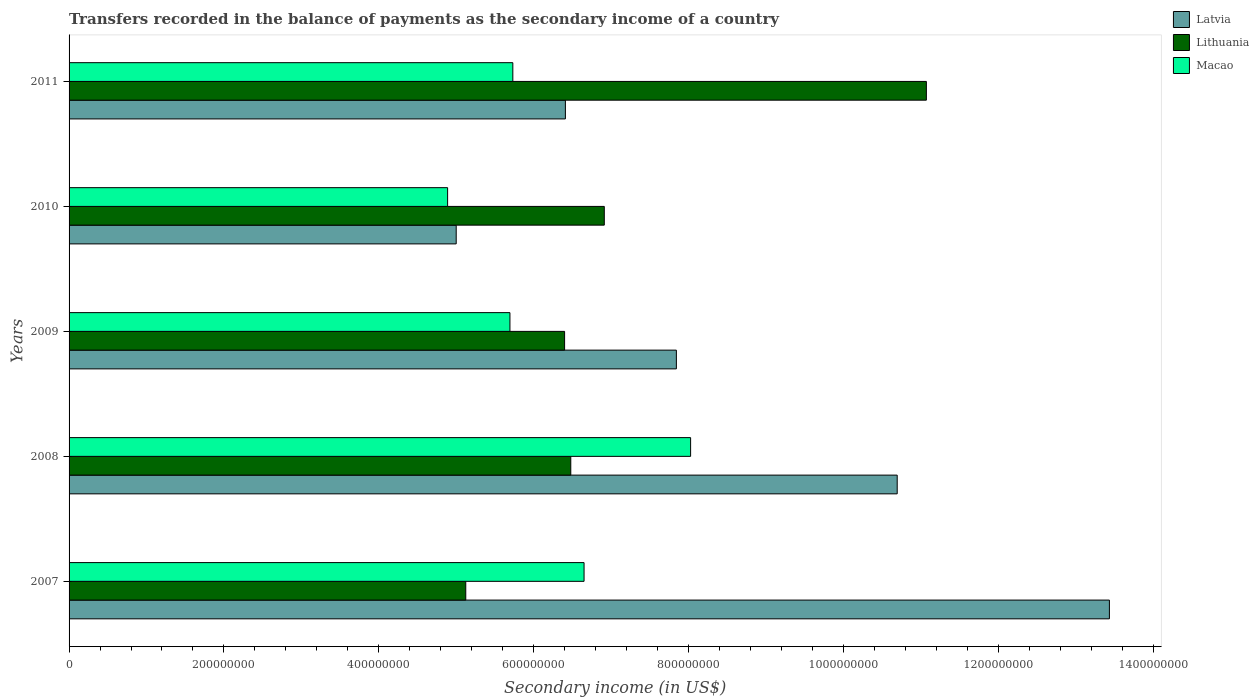How many different coloured bars are there?
Your answer should be compact. 3. Are the number of bars per tick equal to the number of legend labels?
Give a very brief answer. Yes. How many bars are there on the 3rd tick from the bottom?
Provide a short and direct response. 3. What is the label of the 4th group of bars from the top?
Provide a succinct answer. 2008. In how many cases, is the number of bars for a given year not equal to the number of legend labels?
Give a very brief answer. 0. What is the secondary income of in Latvia in 2007?
Provide a succinct answer. 1.34e+09. Across all years, what is the maximum secondary income of in Macao?
Your answer should be very brief. 8.03e+08. Across all years, what is the minimum secondary income of in Lithuania?
Provide a succinct answer. 5.12e+08. What is the total secondary income of in Latvia in the graph?
Your answer should be very brief. 4.34e+09. What is the difference between the secondary income of in Lithuania in 2008 and that in 2011?
Provide a succinct answer. -4.59e+08. What is the difference between the secondary income of in Latvia in 2010 and the secondary income of in Lithuania in 2009?
Your answer should be compact. -1.40e+08. What is the average secondary income of in Latvia per year?
Your answer should be compact. 8.68e+08. In the year 2011, what is the difference between the secondary income of in Lithuania and secondary income of in Latvia?
Give a very brief answer. 4.66e+08. What is the ratio of the secondary income of in Lithuania in 2009 to that in 2010?
Offer a very short reply. 0.93. What is the difference between the highest and the second highest secondary income of in Macao?
Offer a terse response. 1.38e+08. What is the difference between the highest and the lowest secondary income of in Latvia?
Your answer should be compact. 8.44e+08. In how many years, is the secondary income of in Lithuania greater than the average secondary income of in Lithuania taken over all years?
Your answer should be compact. 1. Is the sum of the secondary income of in Latvia in 2008 and 2010 greater than the maximum secondary income of in Macao across all years?
Your answer should be very brief. Yes. What does the 1st bar from the top in 2009 represents?
Offer a very short reply. Macao. What does the 1st bar from the bottom in 2011 represents?
Your response must be concise. Latvia. Is it the case that in every year, the sum of the secondary income of in Lithuania and secondary income of in Latvia is greater than the secondary income of in Macao?
Keep it short and to the point. Yes. Are all the bars in the graph horizontal?
Make the answer very short. Yes. What is the difference between two consecutive major ticks on the X-axis?
Your response must be concise. 2.00e+08. Are the values on the major ticks of X-axis written in scientific E-notation?
Your answer should be very brief. No. How many legend labels are there?
Your response must be concise. 3. How are the legend labels stacked?
Offer a very short reply. Vertical. What is the title of the graph?
Your answer should be very brief. Transfers recorded in the balance of payments as the secondary income of a country. What is the label or title of the X-axis?
Your answer should be compact. Secondary income (in US$). What is the label or title of the Y-axis?
Make the answer very short. Years. What is the Secondary income (in US$) of Latvia in 2007?
Offer a terse response. 1.34e+09. What is the Secondary income (in US$) in Lithuania in 2007?
Your response must be concise. 5.12e+08. What is the Secondary income (in US$) of Macao in 2007?
Keep it short and to the point. 6.65e+08. What is the Secondary income (in US$) of Latvia in 2008?
Make the answer very short. 1.07e+09. What is the Secondary income (in US$) of Lithuania in 2008?
Make the answer very short. 6.48e+08. What is the Secondary income (in US$) of Macao in 2008?
Your answer should be compact. 8.03e+08. What is the Secondary income (in US$) of Latvia in 2009?
Give a very brief answer. 7.84e+08. What is the Secondary income (in US$) of Lithuania in 2009?
Keep it short and to the point. 6.40e+08. What is the Secondary income (in US$) in Macao in 2009?
Ensure brevity in your answer.  5.69e+08. What is the Secondary income (in US$) of Latvia in 2010?
Your answer should be compact. 5.00e+08. What is the Secondary income (in US$) in Lithuania in 2010?
Offer a terse response. 6.91e+08. What is the Secondary income (in US$) of Macao in 2010?
Offer a very short reply. 4.89e+08. What is the Secondary income (in US$) in Latvia in 2011?
Your answer should be compact. 6.41e+08. What is the Secondary income (in US$) of Lithuania in 2011?
Offer a very short reply. 1.11e+09. What is the Secondary income (in US$) of Macao in 2011?
Keep it short and to the point. 5.73e+08. Across all years, what is the maximum Secondary income (in US$) in Latvia?
Offer a terse response. 1.34e+09. Across all years, what is the maximum Secondary income (in US$) of Lithuania?
Provide a succinct answer. 1.11e+09. Across all years, what is the maximum Secondary income (in US$) of Macao?
Your response must be concise. 8.03e+08. Across all years, what is the minimum Secondary income (in US$) of Latvia?
Give a very brief answer. 5.00e+08. Across all years, what is the minimum Secondary income (in US$) of Lithuania?
Make the answer very short. 5.12e+08. Across all years, what is the minimum Secondary income (in US$) in Macao?
Offer a terse response. 4.89e+08. What is the total Secondary income (in US$) of Latvia in the graph?
Ensure brevity in your answer.  4.34e+09. What is the total Secondary income (in US$) in Lithuania in the graph?
Your response must be concise. 3.60e+09. What is the total Secondary income (in US$) in Macao in the graph?
Provide a succinct answer. 3.10e+09. What is the difference between the Secondary income (in US$) of Latvia in 2007 and that in 2008?
Your response must be concise. 2.74e+08. What is the difference between the Secondary income (in US$) in Lithuania in 2007 and that in 2008?
Your response must be concise. -1.36e+08. What is the difference between the Secondary income (in US$) in Macao in 2007 and that in 2008?
Ensure brevity in your answer.  -1.38e+08. What is the difference between the Secondary income (in US$) of Latvia in 2007 and that in 2009?
Make the answer very short. 5.59e+08. What is the difference between the Secondary income (in US$) in Lithuania in 2007 and that in 2009?
Offer a very short reply. -1.28e+08. What is the difference between the Secondary income (in US$) in Macao in 2007 and that in 2009?
Your answer should be compact. 9.57e+07. What is the difference between the Secondary income (in US$) in Latvia in 2007 and that in 2010?
Offer a very short reply. 8.44e+08. What is the difference between the Secondary income (in US$) of Lithuania in 2007 and that in 2010?
Offer a terse response. -1.79e+08. What is the difference between the Secondary income (in US$) of Macao in 2007 and that in 2010?
Your response must be concise. 1.76e+08. What is the difference between the Secondary income (in US$) in Latvia in 2007 and that in 2011?
Provide a short and direct response. 7.03e+08. What is the difference between the Secondary income (in US$) in Lithuania in 2007 and that in 2011?
Your answer should be compact. -5.95e+08. What is the difference between the Secondary income (in US$) in Macao in 2007 and that in 2011?
Make the answer very short. 9.20e+07. What is the difference between the Secondary income (in US$) of Latvia in 2008 and that in 2009?
Your answer should be compact. 2.85e+08. What is the difference between the Secondary income (in US$) in Lithuania in 2008 and that in 2009?
Provide a succinct answer. 7.99e+06. What is the difference between the Secondary income (in US$) in Macao in 2008 and that in 2009?
Ensure brevity in your answer.  2.33e+08. What is the difference between the Secondary income (in US$) in Latvia in 2008 and that in 2010?
Provide a short and direct response. 5.70e+08. What is the difference between the Secondary income (in US$) in Lithuania in 2008 and that in 2010?
Make the answer very short. -4.33e+07. What is the difference between the Secondary income (in US$) of Macao in 2008 and that in 2010?
Make the answer very short. 3.14e+08. What is the difference between the Secondary income (in US$) of Latvia in 2008 and that in 2011?
Make the answer very short. 4.29e+08. What is the difference between the Secondary income (in US$) of Lithuania in 2008 and that in 2011?
Your answer should be compact. -4.59e+08. What is the difference between the Secondary income (in US$) in Macao in 2008 and that in 2011?
Provide a succinct answer. 2.30e+08. What is the difference between the Secondary income (in US$) of Latvia in 2009 and that in 2010?
Ensure brevity in your answer.  2.84e+08. What is the difference between the Secondary income (in US$) in Lithuania in 2009 and that in 2010?
Give a very brief answer. -5.13e+07. What is the difference between the Secondary income (in US$) in Macao in 2009 and that in 2010?
Your response must be concise. 8.05e+07. What is the difference between the Secondary income (in US$) of Latvia in 2009 and that in 2011?
Provide a succinct answer. 1.43e+08. What is the difference between the Secondary income (in US$) in Lithuania in 2009 and that in 2011?
Your response must be concise. -4.67e+08. What is the difference between the Secondary income (in US$) of Macao in 2009 and that in 2011?
Your answer should be compact. -3.74e+06. What is the difference between the Secondary income (in US$) in Latvia in 2010 and that in 2011?
Ensure brevity in your answer.  -1.41e+08. What is the difference between the Secondary income (in US$) of Lithuania in 2010 and that in 2011?
Offer a very short reply. -4.16e+08. What is the difference between the Secondary income (in US$) in Macao in 2010 and that in 2011?
Give a very brief answer. -8.42e+07. What is the difference between the Secondary income (in US$) in Latvia in 2007 and the Secondary income (in US$) in Lithuania in 2008?
Offer a very short reply. 6.96e+08. What is the difference between the Secondary income (in US$) of Latvia in 2007 and the Secondary income (in US$) of Macao in 2008?
Your answer should be very brief. 5.41e+08. What is the difference between the Secondary income (in US$) of Lithuania in 2007 and the Secondary income (in US$) of Macao in 2008?
Provide a succinct answer. -2.90e+08. What is the difference between the Secondary income (in US$) of Latvia in 2007 and the Secondary income (in US$) of Lithuania in 2009?
Your answer should be very brief. 7.04e+08. What is the difference between the Secondary income (in US$) in Latvia in 2007 and the Secondary income (in US$) in Macao in 2009?
Offer a terse response. 7.74e+08. What is the difference between the Secondary income (in US$) of Lithuania in 2007 and the Secondary income (in US$) of Macao in 2009?
Provide a succinct answer. -5.70e+07. What is the difference between the Secondary income (in US$) in Latvia in 2007 and the Secondary income (in US$) in Lithuania in 2010?
Your response must be concise. 6.52e+08. What is the difference between the Secondary income (in US$) in Latvia in 2007 and the Secondary income (in US$) in Macao in 2010?
Your answer should be compact. 8.55e+08. What is the difference between the Secondary income (in US$) of Lithuania in 2007 and the Secondary income (in US$) of Macao in 2010?
Offer a very short reply. 2.35e+07. What is the difference between the Secondary income (in US$) in Latvia in 2007 and the Secondary income (in US$) in Lithuania in 2011?
Ensure brevity in your answer.  2.36e+08. What is the difference between the Secondary income (in US$) in Latvia in 2007 and the Secondary income (in US$) in Macao in 2011?
Offer a very short reply. 7.71e+08. What is the difference between the Secondary income (in US$) of Lithuania in 2007 and the Secondary income (in US$) of Macao in 2011?
Your response must be concise. -6.08e+07. What is the difference between the Secondary income (in US$) of Latvia in 2008 and the Secondary income (in US$) of Lithuania in 2009?
Make the answer very short. 4.30e+08. What is the difference between the Secondary income (in US$) of Latvia in 2008 and the Secondary income (in US$) of Macao in 2009?
Keep it short and to the point. 5.00e+08. What is the difference between the Secondary income (in US$) of Lithuania in 2008 and the Secondary income (in US$) of Macao in 2009?
Give a very brief answer. 7.86e+07. What is the difference between the Secondary income (in US$) of Latvia in 2008 and the Secondary income (in US$) of Lithuania in 2010?
Make the answer very short. 3.78e+08. What is the difference between the Secondary income (in US$) in Latvia in 2008 and the Secondary income (in US$) in Macao in 2010?
Offer a very short reply. 5.81e+08. What is the difference between the Secondary income (in US$) in Lithuania in 2008 and the Secondary income (in US$) in Macao in 2010?
Keep it short and to the point. 1.59e+08. What is the difference between the Secondary income (in US$) of Latvia in 2008 and the Secondary income (in US$) of Lithuania in 2011?
Offer a terse response. -3.77e+07. What is the difference between the Secondary income (in US$) of Latvia in 2008 and the Secondary income (in US$) of Macao in 2011?
Offer a terse response. 4.96e+08. What is the difference between the Secondary income (in US$) in Lithuania in 2008 and the Secondary income (in US$) in Macao in 2011?
Make the answer very short. 7.48e+07. What is the difference between the Secondary income (in US$) in Latvia in 2009 and the Secondary income (in US$) in Lithuania in 2010?
Make the answer very short. 9.31e+07. What is the difference between the Secondary income (in US$) of Latvia in 2009 and the Secondary income (in US$) of Macao in 2010?
Your answer should be compact. 2.95e+08. What is the difference between the Secondary income (in US$) in Lithuania in 2009 and the Secondary income (in US$) in Macao in 2010?
Ensure brevity in your answer.  1.51e+08. What is the difference between the Secondary income (in US$) of Latvia in 2009 and the Secondary income (in US$) of Lithuania in 2011?
Ensure brevity in your answer.  -3.23e+08. What is the difference between the Secondary income (in US$) in Latvia in 2009 and the Secondary income (in US$) in Macao in 2011?
Your answer should be very brief. 2.11e+08. What is the difference between the Secondary income (in US$) in Lithuania in 2009 and the Secondary income (in US$) in Macao in 2011?
Offer a very short reply. 6.68e+07. What is the difference between the Secondary income (in US$) of Latvia in 2010 and the Secondary income (in US$) of Lithuania in 2011?
Your response must be concise. -6.07e+08. What is the difference between the Secondary income (in US$) in Latvia in 2010 and the Secondary income (in US$) in Macao in 2011?
Make the answer very short. -7.31e+07. What is the difference between the Secondary income (in US$) of Lithuania in 2010 and the Secondary income (in US$) of Macao in 2011?
Provide a succinct answer. 1.18e+08. What is the average Secondary income (in US$) in Latvia per year?
Offer a very short reply. 8.68e+08. What is the average Secondary income (in US$) in Lithuania per year?
Ensure brevity in your answer.  7.20e+08. What is the average Secondary income (in US$) of Macao per year?
Keep it short and to the point. 6.20e+08. In the year 2007, what is the difference between the Secondary income (in US$) of Latvia and Secondary income (in US$) of Lithuania?
Offer a very short reply. 8.31e+08. In the year 2007, what is the difference between the Secondary income (in US$) in Latvia and Secondary income (in US$) in Macao?
Offer a terse response. 6.79e+08. In the year 2007, what is the difference between the Secondary income (in US$) of Lithuania and Secondary income (in US$) of Macao?
Your answer should be compact. -1.53e+08. In the year 2008, what is the difference between the Secondary income (in US$) of Latvia and Secondary income (in US$) of Lithuania?
Provide a short and direct response. 4.22e+08. In the year 2008, what is the difference between the Secondary income (in US$) in Latvia and Secondary income (in US$) in Macao?
Give a very brief answer. 2.67e+08. In the year 2008, what is the difference between the Secondary income (in US$) in Lithuania and Secondary income (in US$) in Macao?
Provide a succinct answer. -1.55e+08. In the year 2009, what is the difference between the Secondary income (in US$) of Latvia and Secondary income (in US$) of Lithuania?
Give a very brief answer. 1.44e+08. In the year 2009, what is the difference between the Secondary income (in US$) in Latvia and Secondary income (in US$) in Macao?
Your response must be concise. 2.15e+08. In the year 2009, what is the difference between the Secondary income (in US$) in Lithuania and Secondary income (in US$) in Macao?
Give a very brief answer. 7.06e+07. In the year 2010, what is the difference between the Secondary income (in US$) in Latvia and Secondary income (in US$) in Lithuania?
Provide a succinct answer. -1.91e+08. In the year 2010, what is the difference between the Secondary income (in US$) of Latvia and Secondary income (in US$) of Macao?
Provide a succinct answer. 1.11e+07. In the year 2010, what is the difference between the Secondary income (in US$) in Lithuania and Secondary income (in US$) in Macao?
Provide a short and direct response. 2.02e+08. In the year 2011, what is the difference between the Secondary income (in US$) of Latvia and Secondary income (in US$) of Lithuania?
Offer a very short reply. -4.66e+08. In the year 2011, what is the difference between the Secondary income (in US$) of Latvia and Secondary income (in US$) of Macao?
Offer a terse response. 6.79e+07. In the year 2011, what is the difference between the Secondary income (in US$) of Lithuania and Secondary income (in US$) of Macao?
Offer a terse response. 5.34e+08. What is the ratio of the Secondary income (in US$) in Latvia in 2007 to that in 2008?
Keep it short and to the point. 1.26. What is the ratio of the Secondary income (in US$) in Lithuania in 2007 to that in 2008?
Give a very brief answer. 0.79. What is the ratio of the Secondary income (in US$) in Macao in 2007 to that in 2008?
Your response must be concise. 0.83. What is the ratio of the Secondary income (in US$) in Latvia in 2007 to that in 2009?
Give a very brief answer. 1.71. What is the ratio of the Secondary income (in US$) of Lithuania in 2007 to that in 2009?
Your response must be concise. 0.8. What is the ratio of the Secondary income (in US$) of Macao in 2007 to that in 2009?
Offer a very short reply. 1.17. What is the ratio of the Secondary income (in US$) of Latvia in 2007 to that in 2010?
Provide a succinct answer. 2.69. What is the ratio of the Secondary income (in US$) of Lithuania in 2007 to that in 2010?
Your answer should be very brief. 0.74. What is the ratio of the Secondary income (in US$) in Macao in 2007 to that in 2010?
Offer a terse response. 1.36. What is the ratio of the Secondary income (in US$) of Latvia in 2007 to that in 2011?
Offer a very short reply. 2.1. What is the ratio of the Secondary income (in US$) of Lithuania in 2007 to that in 2011?
Offer a very short reply. 0.46. What is the ratio of the Secondary income (in US$) in Macao in 2007 to that in 2011?
Keep it short and to the point. 1.16. What is the ratio of the Secondary income (in US$) in Latvia in 2008 to that in 2009?
Provide a short and direct response. 1.36. What is the ratio of the Secondary income (in US$) in Lithuania in 2008 to that in 2009?
Provide a succinct answer. 1.01. What is the ratio of the Secondary income (in US$) of Macao in 2008 to that in 2009?
Make the answer very short. 1.41. What is the ratio of the Secondary income (in US$) in Latvia in 2008 to that in 2010?
Offer a very short reply. 2.14. What is the ratio of the Secondary income (in US$) of Lithuania in 2008 to that in 2010?
Provide a short and direct response. 0.94. What is the ratio of the Secondary income (in US$) in Macao in 2008 to that in 2010?
Your answer should be very brief. 1.64. What is the ratio of the Secondary income (in US$) of Latvia in 2008 to that in 2011?
Offer a terse response. 1.67. What is the ratio of the Secondary income (in US$) of Lithuania in 2008 to that in 2011?
Give a very brief answer. 0.59. What is the ratio of the Secondary income (in US$) of Macao in 2008 to that in 2011?
Provide a short and direct response. 1.4. What is the ratio of the Secondary income (in US$) of Latvia in 2009 to that in 2010?
Your response must be concise. 1.57. What is the ratio of the Secondary income (in US$) in Lithuania in 2009 to that in 2010?
Provide a succinct answer. 0.93. What is the ratio of the Secondary income (in US$) of Macao in 2009 to that in 2010?
Your response must be concise. 1.16. What is the ratio of the Secondary income (in US$) in Latvia in 2009 to that in 2011?
Ensure brevity in your answer.  1.22. What is the ratio of the Secondary income (in US$) of Lithuania in 2009 to that in 2011?
Provide a short and direct response. 0.58. What is the ratio of the Secondary income (in US$) in Macao in 2009 to that in 2011?
Give a very brief answer. 0.99. What is the ratio of the Secondary income (in US$) of Latvia in 2010 to that in 2011?
Offer a very short reply. 0.78. What is the ratio of the Secondary income (in US$) in Lithuania in 2010 to that in 2011?
Offer a very short reply. 0.62. What is the ratio of the Secondary income (in US$) of Macao in 2010 to that in 2011?
Provide a succinct answer. 0.85. What is the difference between the highest and the second highest Secondary income (in US$) in Latvia?
Give a very brief answer. 2.74e+08. What is the difference between the highest and the second highest Secondary income (in US$) of Lithuania?
Your response must be concise. 4.16e+08. What is the difference between the highest and the second highest Secondary income (in US$) in Macao?
Make the answer very short. 1.38e+08. What is the difference between the highest and the lowest Secondary income (in US$) in Latvia?
Provide a succinct answer. 8.44e+08. What is the difference between the highest and the lowest Secondary income (in US$) in Lithuania?
Give a very brief answer. 5.95e+08. What is the difference between the highest and the lowest Secondary income (in US$) of Macao?
Your answer should be very brief. 3.14e+08. 